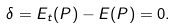Convert formula to latex. <formula><loc_0><loc_0><loc_500><loc_500>\delta = E _ { t } ( P ) - E ( P ) = 0 .</formula> 